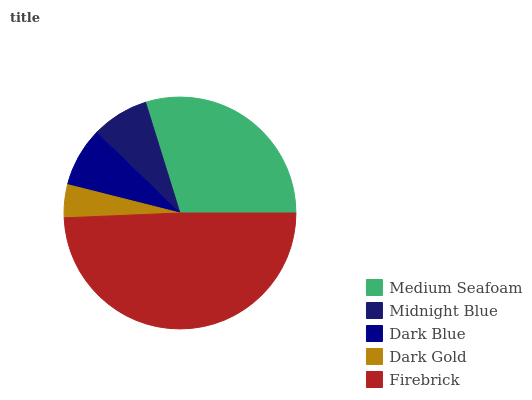Is Dark Gold the minimum?
Answer yes or no. Yes. Is Firebrick the maximum?
Answer yes or no. Yes. Is Midnight Blue the minimum?
Answer yes or no. No. Is Midnight Blue the maximum?
Answer yes or no. No. Is Medium Seafoam greater than Midnight Blue?
Answer yes or no. Yes. Is Midnight Blue less than Medium Seafoam?
Answer yes or no. Yes. Is Midnight Blue greater than Medium Seafoam?
Answer yes or no. No. Is Medium Seafoam less than Midnight Blue?
Answer yes or no. No. Is Dark Blue the high median?
Answer yes or no. Yes. Is Dark Blue the low median?
Answer yes or no. Yes. Is Midnight Blue the high median?
Answer yes or no. No. Is Dark Gold the low median?
Answer yes or no. No. 